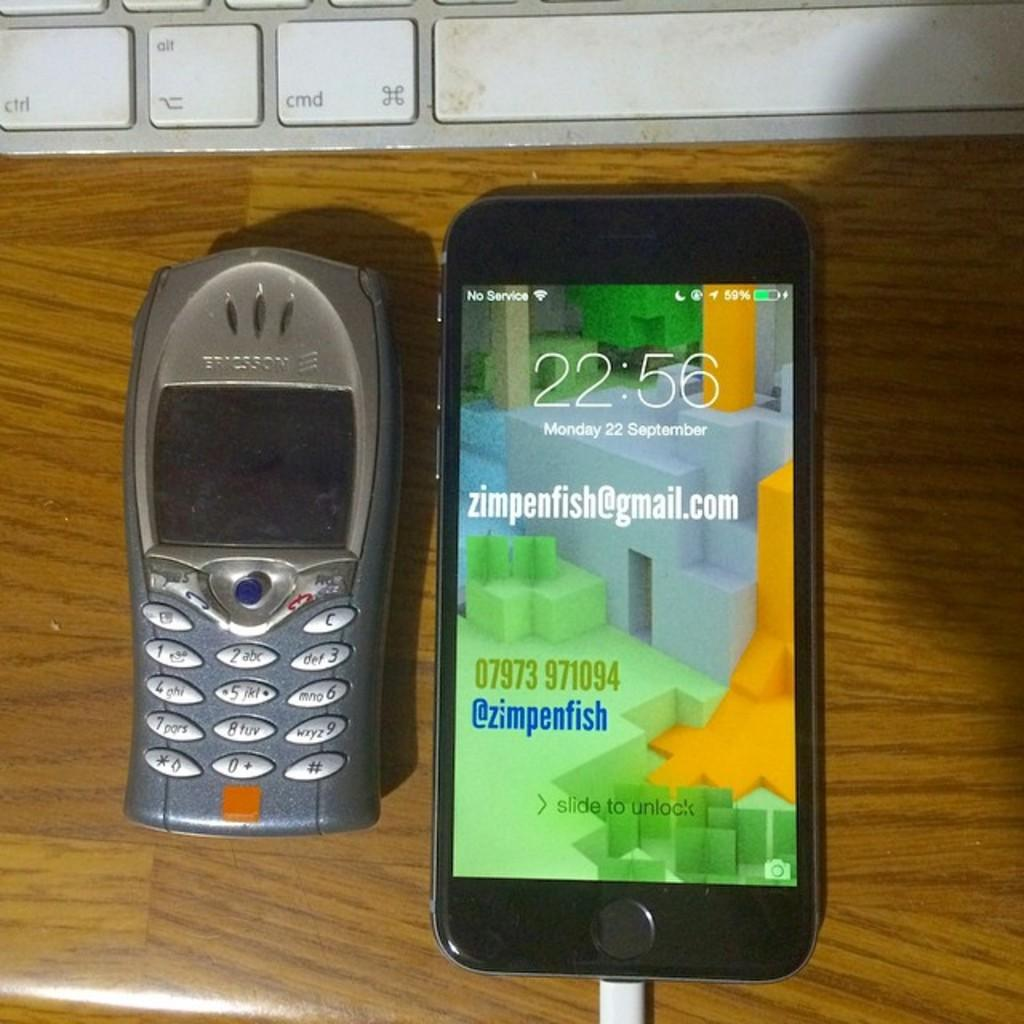Provide a one-sentence caption for the provided image. an older version of a cell phone placed next to a new phone with a screen showing a zimpenfish@gmail.com. 